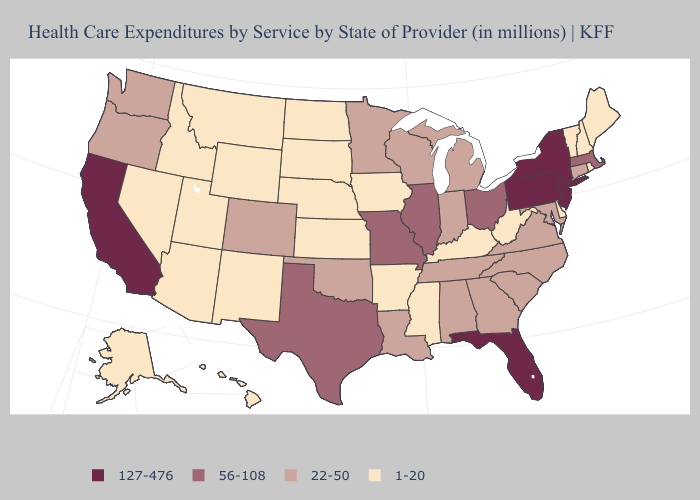How many symbols are there in the legend?
Quick response, please. 4. Name the states that have a value in the range 127-476?
Give a very brief answer. California, Florida, New Jersey, New York, Pennsylvania. Name the states that have a value in the range 22-50?
Concise answer only. Alabama, Colorado, Connecticut, Georgia, Indiana, Louisiana, Maryland, Michigan, Minnesota, North Carolina, Oklahoma, Oregon, South Carolina, Tennessee, Virginia, Washington, Wisconsin. Among the states that border Nebraska , does Iowa have the lowest value?
Give a very brief answer. Yes. What is the lowest value in states that border Vermont?
Short answer required. 1-20. Name the states that have a value in the range 56-108?
Short answer required. Illinois, Massachusetts, Missouri, Ohio, Texas. Does the map have missing data?
Write a very short answer. No. Which states have the lowest value in the USA?
Short answer required. Alaska, Arizona, Arkansas, Delaware, Hawaii, Idaho, Iowa, Kansas, Kentucky, Maine, Mississippi, Montana, Nebraska, Nevada, New Hampshire, New Mexico, North Dakota, Rhode Island, South Dakota, Utah, Vermont, West Virginia, Wyoming. Name the states that have a value in the range 127-476?
Give a very brief answer. California, Florida, New Jersey, New York, Pennsylvania. Does Connecticut have a higher value than Louisiana?
Write a very short answer. No. What is the lowest value in the USA?
Answer briefly. 1-20. What is the value of Georgia?
Short answer required. 22-50. What is the value of Arizona?
Answer briefly. 1-20. What is the value of North Carolina?
Write a very short answer. 22-50. 